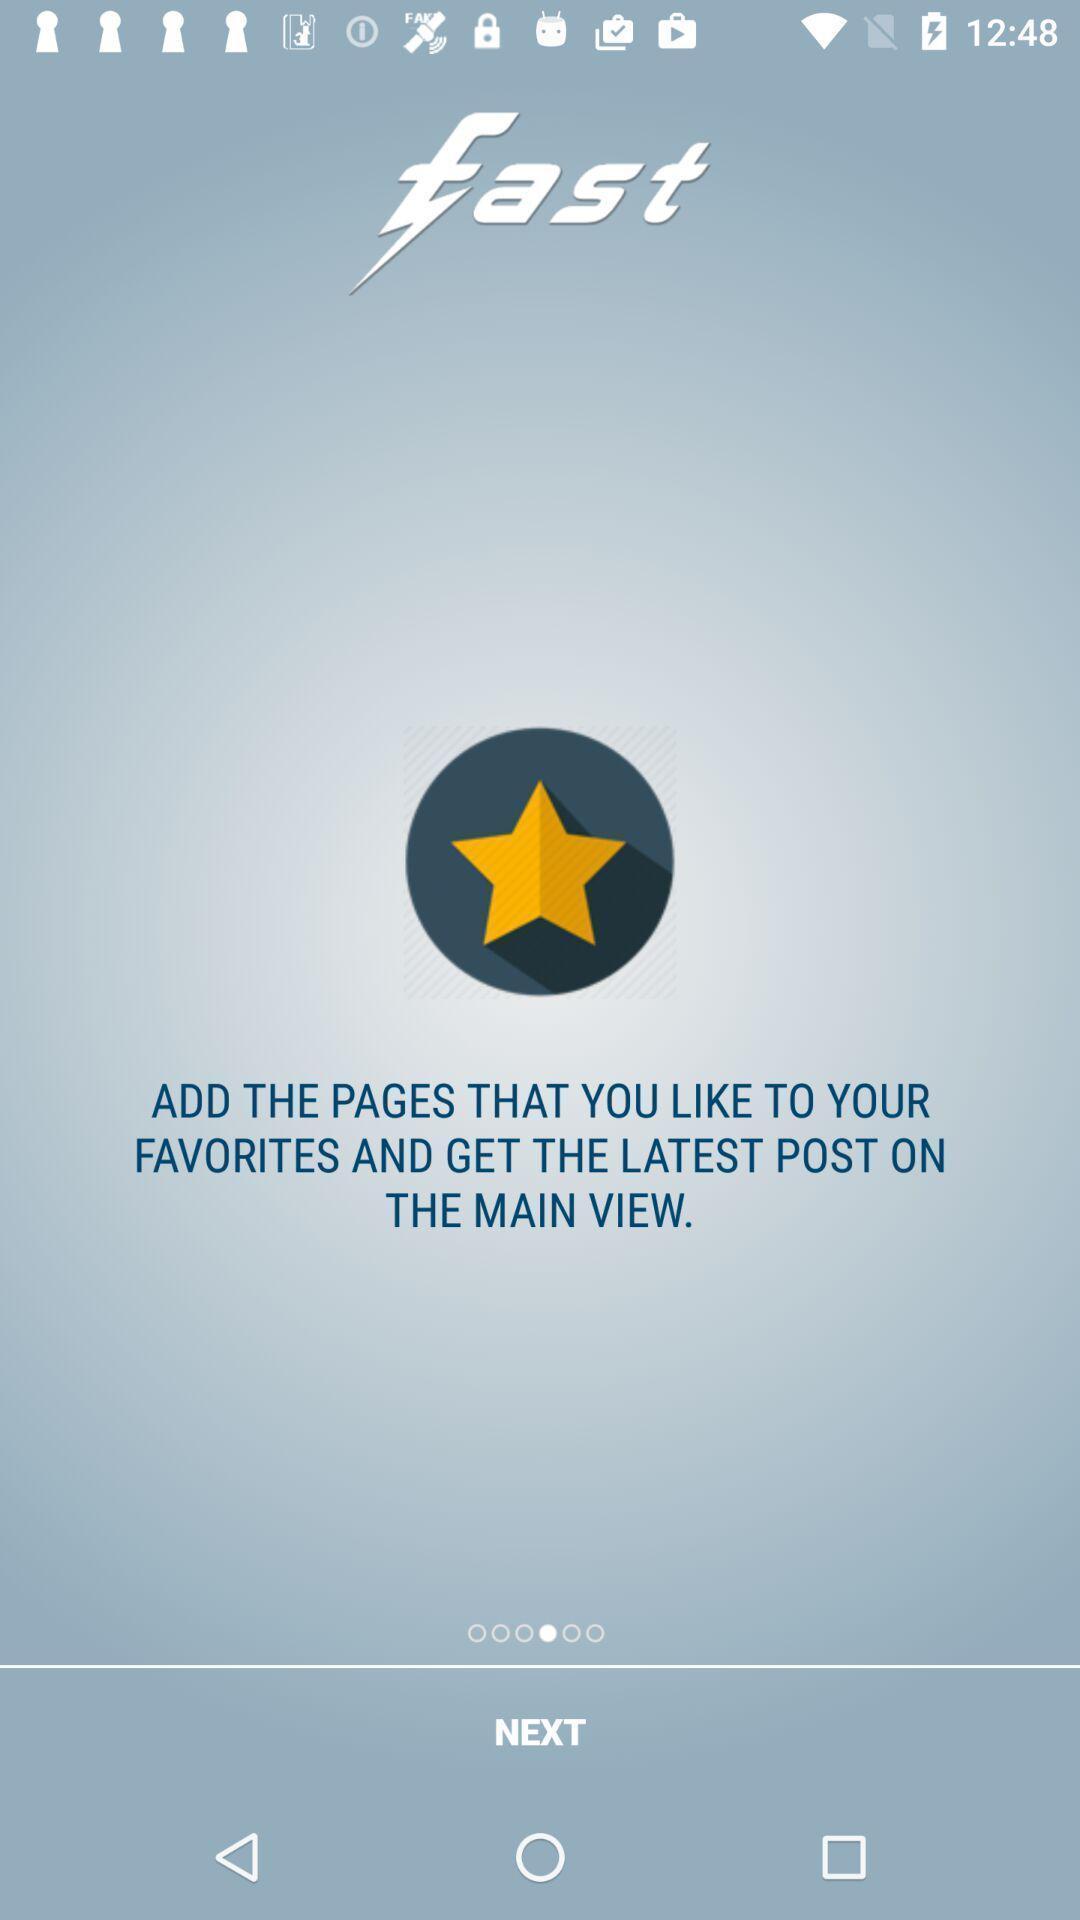Describe the visual elements of this screenshot. Welcome page of social app. 